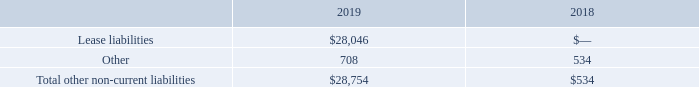Other Non-current Liabilities
Other non-current liabilities consisted of the following (in thousands):
What is the total other non-current liabilities as at 31 December 2018?
Answer scale should be: thousand. $534. What is the total other non-current liabilities as at 31 December 2019?
Answer scale should be: thousand. $28,754. What is the lease liability as at 31 December 2019?
Answer scale should be: thousand. $28,046. What is the percentage change in total other non-current liabilities between 2018 and 2019?
Answer scale should be: percent. (28,754 - 534)/534 
Answer: 5284.64. What is the sum of other liabilities in 2019 and 2018?
Answer scale should be: thousand. 708 + 534 
Answer: 1242. What is the total non-current liabilities between 2018 to 2019?
Answer scale should be: thousand. 28,754+534
Answer: 29288. 